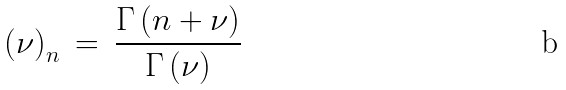Convert formula to latex. <formula><loc_0><loc_0><loc_500><loc_500>\left ( \nu \right ) _ { n } \, = \, \frac { \Gamma \left ( n + \nu \right ) } { \Gamma \left ( \nu \right ) } \,</formula> 